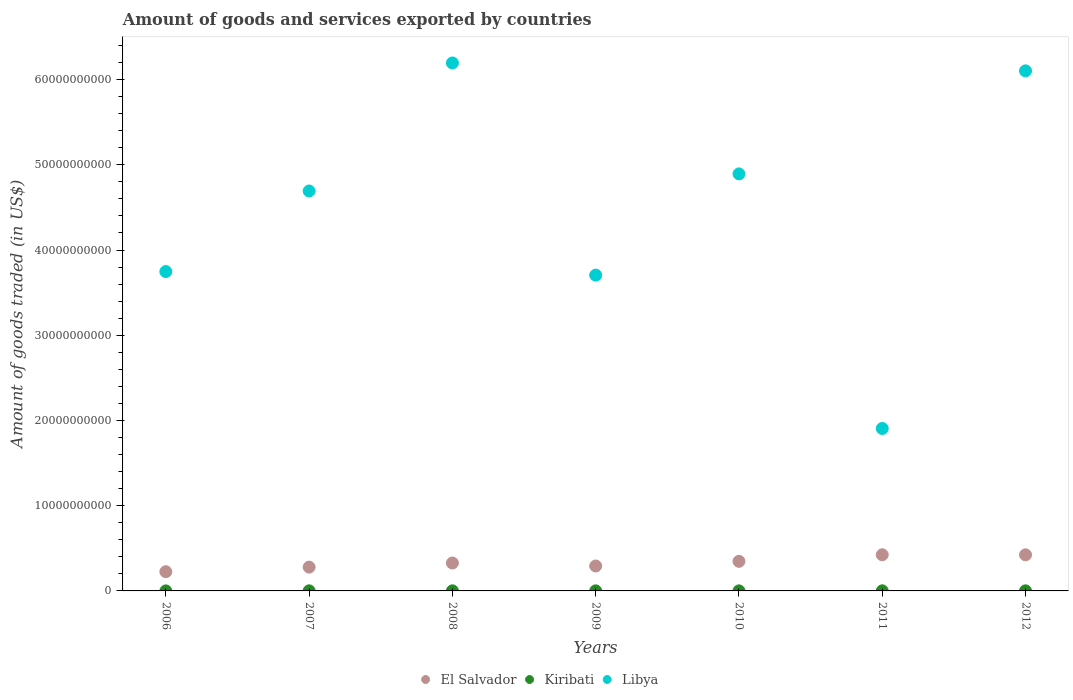How many different coloured dotlines are there?
Keep it short and to the point. 3. Is the number of dotlines equal to the number of legend labels?
Your response must be concise. Yes. What is the total amount of goods and services exported in Libya in 2007?
Offer a very short reply. 4.69e+1. Across all years, what is the maximum total amount of goods and services exported in Libya?
Offer a very short reply. 6.20e+1. Across all years, what is the minimum total amount of goods and services exported in El Salvador?
Provide a succinct answer. 2.25e+09. In which year was the total amount of goods and services exported in Libya maximum?
Your answer should be very brief. 2008. In which year was the total amount of goods and services exported in Libya minimum?
Make the answer very short. 2011. What is the total total amount of goods and services exported in Libya in the graph?
Give a very brief answer. 3.12e+11. What is the difference between the total amount of goods and services exported in Libya in 2009 and that in 2011?
Your response must be concise. 1.80e+1. What is the difference between the total amount of goods and services exported in El Salvador in 2006 and the total amount of goods and services exported in Kiribati in 2011?
Ensure brevity in your answer.  2.24e+09. What is the average total amount of goods and services exported in El Salvador per year?
Provide a succinct answer. 3.31e+09. In the year 2010, what is the difference between the total amount of goods and services exported in El Salvador and total amount of goods and services exported in Kiribati?
Offer a very short reply. 3.47e+09. What is the ratio of the total amount of goods and services exported in Kiribati in 2011 to that in 2012?
Provide a succinct answer. 1.13. Is the total amount of goods and services exported in Libya in 2006 less than that in 2009?
Your answer should be compact. No. What is the difference between the highest and the second highest total amount of goods and services exported in El Salvador?
Your answer should be very brief. 7.78e+06. What is the difference between the highest and the lowest total amount of goods and services exported in Kiribati?
Ensure brevity in your answer.  8.21e+06. In how many years, is the total amount of goods and services exported in Libya greater than the average total amount of goods and services exported in Libya taken over all years?
Offer a terse response. 4. Is it the case that in every year, the sum of the total amount of goods and services exported in Libya and total amount of goods and services exported in El Salvador  is greater than the total amount of goods and services exported in Kiribati?
Ensure brevity in your answer.  Yes. Does the total amount of goods and services exported in Kiribati monotonically increase over the years?
Provide a succinct answer. No. Is the total amount of goods and services exported in Libya strictly less than the total amount of goods and services exported in El Salvador over the years?
Offer a terse response. No. How many years are there in the graph?
Offer a very short reply. 7. What is the difference between two consecutive major ticks on the Y-axis?
Provide a succinct answer. 1.00e+1. Are the values on the major ticks of Y-axis written in scientific E-notation?
Provide a short and direct response. No. Where does the legend appear in the graph?
Ensure brevity in your answer.  Bottom center. How many legend labels are there?
Ensure brevity in your answer.  3. What is the title of the graph?
Give a very brief answer. Amount of goods and services exported by countries. Does "Northern Mariana Islands" appear as one of the legend labels in the graph?
Make the answer very short. No. What is the label or title of the Y-axis?
Offer a terse response. Amount of goods traded (in US$). What is the Amount of goods traded (in US$) of El Salvador in 2006?
Provide a short and direct response. 2.25e+09. What is the Amount of goods traded (in US$) of Kiribati in 2006?
Make the answer very short. 3.27e+06. What is the Amount of goods traded (in US$) in Libya in 2006?
Provide a short and direct response. 3.75e+1. What is the Amount of goods traded (in US$) of El Salvador in 2007?
Your answer should be very brief. 2.79e+09. What is the Amount of goods traded (in US$) in Kiribati in 2007?
Ensure brevity in your answer.  1.13e+07. What is the Amount of goods traded (in US$) in Libya in 2007?
Your answer should be compact. 4.69e+1. What is the Amount of goods traded (in US$) of El Salvador in 2008?
Give a very brief answer. 3.28e+09. What is the Amount of goods traded (in US$) in Kiribati in 2008?
Your response must be concise. 9.18e+06. What is the Amount of goods traded (in US$) of Libya in 2008?
Offer a terse response. 6.20e+1. What is the Amount of goods traded (in US$) of El Salvador in 2009?
Your answer should be compact. 2.92e+09. What is the Amount of goods traded (in US$) in Kiribati in 2009?
Keep it short and to the point. 7.42e+06. What is the Amount of goods traded (in US$) in Libya in 2009?
Give a very brief answer. 3.71e+1. What is the Amount of goods traded (in US$) in El Salvador in 2010?
Your answer should be very brief. 3.47e+09. What is the Amount of goods traded (in US$) in Kiribati in 2010?
Provide a short and direct response. 6.66e+06. What is the Amount of goods traded (in US$) of Libya in 2010?
Offer a very short reply. 4.89e+1. What is the Amount of goods traded (in US$) in El Salvador in 2011?
Offer a very short reply. 4.24e+09. What is the Amount of goods traded (in US$) in Kiribati in 2011?
Offer a very short reply. 1.15e+07. What is the Amount of goods traded (in US$) of Libya in 2011?
Your response must be concise. 1.91e+1. What is the Amount of goods traded (in US$) of El Salvador in 2012?
Offer a very short reply. 4.23e+09. What is the Amount of goods traded (in US$) in Kiribati in 2012?
Keep it short and to the point. 1.02e+07. What is the Amount of goods traded (in US$) of Libya in 2012?
Give a very brief answer. 6.10e+1. Across all years, what is the maximum Amount of goods traded (in US$) in El Salvador?
Provide a succinct answer. 4.24e+09. Across all years, what is the maximum Amount of goods traded (in US$) of Kiribati?
Give a very brief answer. 1.15e+07. Across all years, what is the maximum Amount of goods traded (in US$) of Libya?
Offer a very short reply. 6.20e+1. Across all years, what is the minimum Amount of goods traded (in US$) of El Salvador?
Provide a succinct answer. 2.25e+09. Across all years, what is the minimum Amount of goods traded (in US$) in Kiribati?
Give a very brief answer. 3.27e+06. Across all years, what is the minimum Amount of goods traded (in US$) in Libya?
Offer a very short reply. 1.91e+1. What is the total Amount of goods traded (in US$) in El Salvador in the graph?
Your response must be concise. 2.32e+1. What is the total Amount of goods traded (in US$) in Kiribati in the graph?
Keep it short and to the point. 5.95e+07. What is the total Amount of goods traded (in US$) in Libya in the graph?
Make the answer very short. 3.12e+11. What is the difference between the Amount of goods traded (in US$) of El Salvador in 2006 and that in 2007?
Your response must be concise. -5.39e+08. What is the difference between the Amount of goods traded (in US$) in Kiribati in 2006 and that in 2007?
Provide a succinct answer. -7.99e+06. What is the difference between the Amount of goods traded (in US$) of Libya in 2006 and that in 2007?
Keep it short and to the point. -9.46e+09. What is the difference between the Amount of goods traded (in US$) in El Salvador in 2006 and that in 2008?
Offer a very short reply. -1.02e+09. What is the difference between the Amount of goods traded (in US$) in Kiribati in 2006 and that in 2008?
Your answer should be compact. -5.91e+06. What is the difference between the Amount of goods traded (in US$) in Libya in 2006 and that in 2008?
Offer a very short reply. -2.45e+1. What is the difference between the Amount of goods traded (in US$) in El Salvador in 2006 and that in 2009?
Your answer should be very brief. -6.69e+08. What is the difference between the Amount of goods traded (in US$) of Kiribati in 2006 and that in 2009?
Ensure brevity in your answer.  -4.14e+06. What is the difference between the Amount of goods traded (in US$) in Libya in 2006 and that in 2009?
Offer a very short reply. 4.18e+08. What is the difference between the Amount of goods traded (in US$) in El Salvador in 2006 and that in 2010?
Your answer should be very brief. -1.22e+09. What is the difference between the Amount of goods traded (in US$) of Kiribati in 2006 and that in 2010?
Provide a succinct answer. -3.39e+06. What is the difference between the Amount of goods traded (in US$) of Libya in 2006 and that in 2010?
Your answer should be very brief. -1.15e+1. What is the difference between the Amount of goods traded (in US$) of El Salvador in 2006 and that in 2011?
Provide a short and direct response. -1.99e+09. What is the difference between the Amount of goods traded (in US$) in Kiribati in 2006 and that in 2011?
Your answer should be compact. -8.21e+06. What is the difference between the Amount of goods traded (in US$) in Libya in 2006 and that in 2011?
Offer a very short reply. 1.84e+1. What is the difference between the Amount of goods traded (in US$) of El Salvador in 2006 and that in 2012?
Ensure brevity in your answer.  -1.98e+09. What is the difference between the Amount of goods traded (in US$) of Kiribati in 2006 and that in 2012?
Make the answer very short. -6.92e+06. What is the difference between the Amount of goods traded (in US$) in Libya in 2006 and that in 2012?
Keep it short and to the point. -2.36e+1. What is the difference between the Amount of goods traded (in US$) in El Salvador in 2007 and that in 2008?
Your answer should be very brief. -4.82e+08. What is the difference between the Amount of goods traded (in US$) in Kiribati in 2007 and that in 2008?
Your response must be concise. 2.08e+06. What is the difference between the Amount of goods traded (in US$) in Libya in 2007 and that in 2008?
Your response must be concise. -1.50e+1. What is the difference between the Amount of goods traded (in US$) of El Salvador in 2007 and that in 2009?
Offer a very short reply. -1.30e+08. What is the difference between the Amount of goods traded (in US$) in Kiribati in 2007 and that in 2009?
Your response must be concise. 3.85e+06. What is the difference between the Amount of goods traded (in US$) in Libya in 2007 and that in 2009?
Make the answer very short. 9.87e+09. What is the difference between the Amount of goods traded (in US$) in El Salvador in 2007 and that in 2010?
Give a very brief answer. -6.79e+08. What is the difference between the Amount of goods traded (in US$) in Kiribati in 2007 and that in 2010?
Your response must be concise. 4.60e+06. What is the difference between the Amount of goods traded (in US$) in Libya in 2007 and that in 2010?
Make the answer very short. -2.01e+09. What is the difference between the Amount of goods traded (in US$) of El Salvador in 2007 and that in 2011?
Offer a very short reply. -1.45e+09. What is the difference between the Amount of goods traded (in US$) in Kiribati in 2007 and that in 2011?
Offer a very short reply. -2.15e+05. What is the difference between the Amount of goods traded (in US$) in Libya in 2007 and that in 2011?
Offer a very short reply. 2.79e+1. What is the difference between the Amount of goods traded (in US$) in El Salvador in 2007 and that in 2012?
Keep it short and to the point. -1.44e+09. What is the difference between the Amount of goods traded (in US$) of Kiribati in 2007 and that in 2012?
Your answer should be very brief. 1.07e+06. What is the difference between the Amount of goods traded (in US$) of Libya in 2007 and that in 2012?
Offer a terse response. -1.41e+1. What is the difference between the Amount of goods traded (in US$) of El Salvador in 2008 and that in 2009?
Keep it short and to the point. 3.52e+08. What is the difference between the Amount of goods traded (in US$) in Kiribati in 2008 and that in 2009?
Make the answer very short. 1.76e+06. What is the difference between the Amount of goods traded (in US$) in Libya in 2008 and that in 2009?
Ensure brevity in your answer.  2.49e+1. What is the difference between the Amount of goods traded (in US$) of El Salvador in 2008 and that in 2010?
Ensure brevity in your answer.  -1.98e+08. What is the difference between the Amount of goods traded (in US$) of Kiribati in 2008 and that in 2010?
Provide a succinct answer. 2.52e+06. What is the difference between the Amount of goods traded (in US$) of Libya in 2008 and that in 2010?
Make the answer very short. 1.30e+1. What is the difference between the Amount of goods traded (in US$) of El Salvador in 2008 and that in 2011?
Provide a short and direct response. -9.67e+08. What is the difference between the Amount of goods traded (in US$) in Kiribati in 2008 and that in 2011?
Your response must be concise. -2.30e+06. What is the difference between the Amount of goods traded (in US$) of Libya in 2008 and that in 2011?
Your response must be concise. 4.29e+1. What is the difference between the Amount of goods traded (in US$) of El Salvador in 2008 and that in 2012?
Keep it short and to the point. -9.59e+08. What is the difference between the Amount of goods traded (in US$) of Kiribati in 2008 and that in 2012?
Offer a terse response. -1.01e+06. What is the difference between the Amount of goods traded (in US$) of Libya in 2008 and that in 2012?
Your answer should be compact. 9.24e+08. What is the difference between the Amount of goods traded (in US$) of El Salvador in 2009 and that in 2010?
Ensure brevity in your answer.  -5.50e+08. What is the difference between the Amount of goods traded (in US$) in Kiribati in 2009 and that in 2010?
Provide a short and direct response. 7.58e+05. What is the difference between the Amount of goods traded (in US$) in Libya in 2009 and that in 2010?
Ensure brevity in your answer.  -1.19e+1. What is the difference between the Amount of goods traded (in US$) in El Salvador in 2009 and that in 2011?
Ensure brevity in your answer.  -1.32e+09. What is the difference between the Amount of goods traded (in US$) in Kiribati in 2009 and that in 2011?
Your response must be concise. -4.06e+06. What is the difference between the Amount of goods traded (in US$) of Libya in 2009 and that in 2011?
Offer a very short reply. 1.80e+1. What is the difference between the Amount of goods traded (in US$) in El Salvador in 2009 and that in 2012?
Give a very brief answer. -1.31e+09. What is the difference between the Amount of goods traded (in US$) of Kiribati in 2009 and that in 2012?
Give a very brief answer. -2.77e+06. What is the difference between the Amount of goods traded (in US$) of Libya in 2009 and that in 2012?
Provide a succinct answer. -2.40e+1. What is the difference between the Amount of goods traded (in US$) of El Salvador in 2010 and that in 2011?
Provide a short and direct response. -7.69e+08. What is the difference between the Amount of goods traded (in US$) of Kiribati in 2010 and that in 2011?
Keep it short and to the point. -4.82e+06. What is the difference between the Amount of goods traded (in US$) in Libya in 2010 and that in 2011?
Ensure brevity in your answer.  2.99e+1. What is the difference between the Amount of goods traded (in US$) in El Salvador in 2010 and that in 2012?
Keep it short and to the point. -7.62e+08. What is the difference between the Amount of goods traded (in US$) of Kiribati in 2010 and that in 2012?
Your answer should be very brief. -3.53e+06. What is the difference between the Amount of goods traded (in US$) in Libya in 2010 and that in 2012?
Ensure brevity in your answer.  -1.21e+1. What is the difference between the Amount of goods traded (in US$) in El Salvador in 2011 and that in 2012?
Provide a succinct answer. 7.78e+06. What is the difference between the Amount of goods traded (in US$) of Kiribati in 2011 and that in 2012?
Your answer should be compact. 1.29e+06. What is the difference between the Amount of goods traded (in US$) in Libya in 2011 and that in 2012?
Offer a very short reply. -4.20e+1. What is the difference between the Amount of goods traded (in US$) in El Salvador in 2006 and the Amount of goods traded (in US$) in Kiribati in 2007?
Keep it short and to the point. 2.24e+09. What is the difference between the Amount of goods traded (in US$) of El Salvador in 2006 and the Amount of goods traded (in US$) of Libya in 2007?
Give a very brief answer. -4.47e+1. What is the difference between the Amount of goods traded (in US$) in Kiribati in 2006 and the Amount of goods traded (in US$) in Libya in 2007?
Make the answer very short. -4.69e+1. What is the difference between the Amount of goods traded (in US$) of El Salvador in 2006 and the Amount of goods traded (in US$) of Kiribati in 2008?
Your answer should be very brief. 2.25e+09. What is the difference between the Amount of goods traded (in US$) of El Salvador in 2006 and the Amount of goods traded (in US$) of Libya in 2008?
Your answer should be compact. -5.97e+1. What is the difference between the Amount of goods traded (in US$) in Kiribati in 2006 and the Amount of goods traded (in US$) in Libya in 2008?
Give a very brief answer. -6.19e+1. What is the difference between the Amount of goods traded (in US$) in El Salvador in 2006 and the Amount of goods traded (in US$) in Kiribati in 2009?
Provide a short and direct response. 2.25e+09. What is the difference between the Amount of goods traded (in US$) in El Salvador in 2006 and the Amount of goods traded (in US$) in Libya in 2009?
Make the answer very short. -3.48e+1. What is the difference between the Amount of goods traded (in US$) in Kiribati in 2006 and the Amount of goods traded (in US$) in Libya in 2009?
Your answer should be very brief. -3.71e+1. What is the difference between the Amount of goods traded (in US$) in El Salvador in 2006 and the Amount of goods traded (in US$) in Kiribati in 2010?
Your answer should be compact. 2.25e+09. What is the difference between the Amount of goods traded (in US$) in El Salvador in 2006 and the Amount of goods traded (in US$) in Libya in 2010?
Keep it short and to the point. -4.67e+1. What is the difference between the Amount of goods traded (in US$) in Kiribati in 2006 and the Amount of goods traded (in US$) in Libya in 2010?
Provide a succinct answer. -4.89e+1. What is the difference between the Amount of goods traded (in US$) in El Salvador in 2006 and the Amount of goods traded (in US$) in Kiribati in 2011?
Your response must be concise. 2.24e+09. What is the difference between the Amount of goods traded (in US$) of El Salvador in 2006 and the Amount of goods traded (in US$) of Libya in 2011?
Your answer should be compact. -1.68e+1. What is the difference between the Amount of goods traded (in US$) in Kiribati in 2006 and the Amount of goods traded (in US$) in Libya in 2011?
Your answer should be compact. -1.91e+1. What is the difference between the Amount of goods traded (in US$) in El Salvador in 2006 and the Amount of goods traded (in US$) in Kiribati in 2012?
Keep it short and to the point. 2.24e+09. What is the difference between the Amount of goods traded (in US$) in El Salvador in 2006 and the Amount of goods traded (in US$) in Libya in 2012?
Keep it short and to the point. -5.88e+1. What is the difference between the Amount of goods traded (in US$) in Kiribati in 2006 and the Amount of goods traded (in US$) in Libya in 2012?
Provide a short and direct response. -6.10e+1. What is the difference between the Amount of goods traded (in US$) of El Salvador in 2007 and the Amount of goods traded (in US$) of Kiribati in 2008?
Offer a very short reply. 2.78e+09. What is the difference between the Amount of goods traded (in US$) of El Salvador in 2007 and the Amount of goods traded (in US$) of Libya in 2008?
Offer a terse response. -5.92e+1. What is the difference between the Amount of goods traded (in US$) in Kiribati in 2007 and the Amount of goods traded (in US$) in Libya in 2008?
Your answer should be very brief. -6.19e+1. What is the difference between the Amount of goods traded (in US$) of El Salvador in 2007 and the Amount of goods traded (in US$) of Kiribati in 2009?
Offer a terse response. 2.79e+09. What is the difference between the Amount of goods traded (in US$) of El Salvador in 2007 and the Amount of goods traded (in US$) of Libya in 2009?
Keep it short and to the point. -3.43e+1. What is the difference between the Amount of goods traded (in US$) in Kiribati in 2007 and the Amount of goods traded (in US$) in Libya in 2009?
Provide a short and direct response. -3.70e+1. What is the difference between the Amount of goods traded (in US$) of El Salvador in 2007 and the Amount of goods traded (in US$) of Kiribati in 2010?
Offer a very short reply. 2.79e+09. What is the difference between the Amount of goods traded (in US$) in El Salvador in 2007 and the Amount of goods traded (in US$) in Libya in 2010?
Offer a terse response. -4.61e+1. What is the difference between the Amount of goods traded (in US$) of Kiribati in 2007 and the Amount of goods traded (in US$) of Libya in 2010?
Provide a succinct answer. -4.89e+1. What is the difference between the Amount of goods traded (in US$) of El Salvador in 2007 and the Amount of goods traded (in US$) of Kiribati in 2011?
Your answer should be very brief. 2.78e+09. What is the difference between the Amount of goods traded (in US$) of El Salvador in 2007 and the Amount of goods traded (in US$) of Libya in 2011?
Make the answer very short. -1.63e+1. What is the difference between the Amount of goods traded (in US$) of Kiribati in 2007 and the Amount of goods traded (in US$) of Libya in 2011?
Give a very brief answer. -1.90e+1. What is the difference between the Amount of goods traded (in US$) of El Salvador in 2007 and the Amount of goods traded (in US$) of Kiribati in 2012?
Keep it short and to the point. 2.78e+09. What is the difference between the Amount of goods traded (in US$) of El Salvador in 2007 and the Amount of goods traded (in US$) of Libya in 2012?
Keep it short and to the point. -5.82e+1. What is the difference between the Amount of goods traded (in US$) of Kiribati in 2007 and the Amount of goods traded (in US$) of Libya in 2012?
Ensure brevity in your answer.  -6.10e+1. What is the difference between the Amount of goods traded (in US$) of El Salvador in 2008 and the Amount of goods traded (in US$) of Kiribati in 2009?
Your answer should be compact. 3.27e+09. What is the difference between the Amount of goods traded (in US$) in El Salvador in 2008 and the Amount of goods traded (in US$) in Libya in 2009?
Your response must be concise. -3.38e+1. What is the difference between the Amount of goods traded (in US$) in Kiribati in 2008 and the Amount of goods traded (in US$) in Libya in 2009?
Make the answer very short. -3.70e+1. What is the difference between the Amount of goods traded (in US$) in El Salvador in 2008 and the Amount of goods traded (in US$) in Kiribati in 2010?
Ensure brevity in your answer.  3.27e+09. What is the difference between the Amount of goods traded (in US$) of El Salvador in 2008 and the Amount of goods traded (in US$) of Libya in 2010?
Provide a succinct answer. -4.57e+1. What is the difference between the Amount of goods traded (in US$) in Kiribati in 2008 and the Amount of goods traded (in US$) in Libya in 2010?
Offer a very short reply. -4.89e+1. What is the difference between the Amount of goods traded (in US$) in El Salvador in 2008 and the Amount of goods traded (in US$) in Kiribati in 2011?
Keep it short and to the point. 3.26e+09. What is the difference between the Amount of goods traded (in US$) in El Salvador in 2008 and the Amount of goods traded (in US$) in Libya in 2011?
Make the answer very short. -1.58e+1. What is the difference between the Amount of goods traded (in US$) of Kiribati in 2008 and the Amount of goods traded (in US$) of Libya in 2011?
Make the answer very short. -1.91e+1. What is the difference between the Amount of goods traded (in US$) of El Salvador in 2008 and the Amount of goods traded (in US$) of Kiribati in 2012?
Your response must be concise. 3.27e+09. What is the difference between the Amount of goods traded (in US$) of El Salvador in 2008 and the Amount of goods traded (in US$) of Libya in 2012?
Your response must be concise. -5.78e+1. What is the difference between the Amount of goods traded (in US$) in Kiribati in 2008 and the Amount of goods traded (in US$) in Libya in 2012?
Your answer should be compact. -6.10e+1. What is the difference between the Amount of goods traded (in US$) of El Salvador in 2009 and the Amount of goods traded (in US$) of Kiribati in 2010?
Ensure brevity in your answer.  2.92e+09. What is the difference between the Amount of goods traded (in US$) of El Salvador in 2009 and the Amount of goods traded (in US$) of Libya in 2010?
Ensure brevity in your answer.  -4.60e+1. What is the difference between the Amount of goods traded (in US$) in Kiribati in 2009 and the Amount of goods traded (in US$) in Libya in 2010?
Offer a very short reply. -4.89e+1. What is the difference between the Amount of goods traded (in US$) in El Salvador in 2009 and the Amount of goods traded (in US$) in Kiribati in 2011?
Make the answer very short. 2.91e+09. What is the difference between the Amount of goods traded (in US$) in El Salvador in 2009 and the Amount of goods traded (in US$) in Libya in 2011?
Make the answer very short. -1.61e+1. What is the difference between the Amount of goods traded (in US$) of Kiribati in 2009 and the Amount of goods traded (in US$) of Libya in 2011?
Provide a succinct answer. -1.91e+1. What is the difference between the Amount of goods traded (in US$) in El Salvador in 2009 and the Amount of goods traded (in US$) in Kiribati in 2012?
Make the answer very short. 2.91e+09. What is the difference between the Amount of goods traded (in US$) of El Salvador in 2009 and the Amount of goods traded (in US$) of Libya in 2012?
Your response must be concise. -5.81e+1. What is the difference between the Amount of goods traded (in US$) in Kiribati in 2009 and the Amount of goods traded (in US$) in Libya in 2012?
Provide a succinct answer. -6.10e+1. What is the difference between the Amount of goods traded (in US$) in El Salvador in 2010 and the Amount of goods traded (in US$) in Kiribati in 2011?
Offer a terse response. 3.46e+09. What is the difference between the Amount of goods traded (in US$) of El Salvador in 2010 and the Amount of goods traded (in US$) of Libya in 2011?
Offer a terse response. -1.56e+1. What is the difference between the Amount of goods traded (in US$) of Kiribati in 2010 and the Amount of goods traded (in US$) of Libya in 2011?
Offer a terse response. -1.91e+1. What is the difference between the Amount of goods traded (in US$) in El Salvador in 2010 and the Amount of goods traded (in US$) in Kiribati in 2012?
Offer a very short reply. 3.46e+09. What is the difference between the Amount of goods traded (in US$) in El Salvador in 2010 and the Amount of goods traded (in US$) in Libya in 2012?
Your answer should be compact. -5.76e+1. What is the difference between the Amount of goods traded (in US$) of Kiribati in 2010 and the Amount of goods traded (in US$) of Libya in 2012?
Your response must be concise. -6.10e+1. What is the difference between the Amount of goods traded (in US$) of El Salvador in 2011 and the Amount of goods traded (in US$) of Kiribati in 2012?
Provide a short and direct response. 4.23e+09. What is the difference between the Amount of goods traded (in US$) in El Salvador in 2011 and the Amount of goods traded (in US$) in Libya in 2012?
Keep it short and to the point. -5.68e+1. What is the difference between the Amount of goods traded (in US$) in Kiribati in 2011 and the Amount of goods traded (in US$) in Libya in 2012?
Keep it short and to the point. -6.10e+1. What is the average Amount of goods traded (in US$) of El Salvador per year?
Your response must be concise. 3.31e+09. What is the average Amount of goods traded (in US$) in Kiribati per year?
Your answer should be compact. 8.49e+06. What is the average Amount of goods traded (in US$) in Libya per year?
Keep it short and to the point. 4.46e+1. In the year 2006, what is the difference between the Amount of goods traded (in US$) of El Salvador and Amount of goods traded (in US$) of Kiribati?
Ensure brevity in your answer.  2.25e+09. In the year 2006, what is the difference between the Amount of goods traded (in US$) of El Salvador and Amount of goods traded (in US$) of Libya?
Make the answer very short. -3.52e+1. In the year 2006, what is the difference between the Amount of goods traded (in US$) in Kiribati and Amount of goods traded (in US$) in Libya?
Ensure brevity in your answer.  -3.75e+1. In the year 2007, what is the difference between the Amount of goods traded (in US$) of El Salvador and Amount of goods traded (in US$) of Kiribati?
Your response must be concise. 2.78e+09. In the year 2007, what is the difference between the Amount of goods traded (in US$) in El Salvador and Amount of goods traded (in US$) in Libya?
Provide a short and direct response. -4.41e+1. In the year 2007, what is the difference between the Amount of goods traded (in US$) of Kiribati and Amount of goods traded (in US$) of Libya?
Offer a very short reply. -4.69e+1. In the year 2008, what is the difference between the Amount of goods traded (in US$) of El Salvador and Amount of goods traded (in US$) of Kiribati?
Your answer should be compact. 3.27e+09. In the year 2008, what is the difference between the Amount of goods traded (in US$) in El Salvador and Amount of goods traded (in US$) in Libya?
Your answer should be compact. -5.87e+1. In the year 2008, what is the difference between the Amount of goods traded (in US$) in Kiribati and Amount of goods traded (in US$) in Libya?
Your answer should be compact. -6.19e+1. In the year 2009, what is the difference between the Amount of goods traded (in US$) of El Salvador and Amount of goods traded (in US$) of Kiribati?
Make the answer very short. 2.92e+09. In the year 2009, what is the difference between the Amount of goods traded (in US$) of El Salvador and Amount of goods traded (in US$) of Libya?
Provide a succinct answer. -3.41e+1. In the year 2009, what is the difference between the Amount of goods traded (in US$) of Kiribati and Amount of goods traded (in US$) of Libya?
Your answer should be very brief. -3.70e+1. In the year 2010, what is the difference between the Amount of goods traded (in US$) of El Salvador and Amount of goods traded (in US$) of Kiribati?
Make the answer very short. 3.47e+09. In the year 2010, what is the difference between the Amount of goods traded (in US$) in El Salvador and Amount of goods traded (in US$) in Libya?
Your answer should be compact. -4.55e+1. In the year 2010, what is the difference between the Amount of goods traded (in US$) in Kiribati and Amount of goods traded (in US$) in Libya?
Keep it short and to the point. -4.89e+1. In the year 2011, what is the difference between the Amount of goods traded (in US$) of El Salvador and Amount of goods traded (in US$) of Kiribati?
Offer a very short reply. 4.23e+09. In the year 2011, what is the difference between the Amount of goods traded (in US$) in El Salvador and Amount of goods traded (in US$) in Libya?
Offer a terse response. -1.48e+1. In the year 2011, what is the difference between the Amount of goods traded (in US$) of Kiribati and Amount of goods traded (in US$) of Libya?
Your answer should be very brief. -1.90e+1. In the year 2012, what is the difference between the Amount of goods traded (in US$) in El Salvador and Amount of goods traded (in US$) in Kiribati?
Give a very brief answer. 4.22e+09. In the year 2012, what is the difference between the Amount of goods traded (in US$) of El Salvador and Amount of goods traded (in US$) of Libya?
Offer a terse response. -5.68e+1. In the year 2012, what is the difference between the Amount of goods traded (in US$) of Kiribati and Amount of goods traded (in US$) of Libya?
Offer a very short reply. -6.10e+1. What is the ratio of the Amount of goods traded (in US$) of El Salvador in 2006 to that in 2007?
Your response must be concise. 0.81. What is the ratio of the Amount of goods traded (in US$) of Kiribati in 2006 to that in 2007?
Give a very brief answer. 0.29. What is the ratio of the Amount of goods traded (in US$) of Libya in 2006 to that in 2007?
Ensure brevity in your answer.  0.8. What is the ratio of the Amount of goods traded (in US$) in El Salvador in 2006 to that in 2008?
Make the answer very short. 0.69. What is the ratio of the Amount of goods traded (in US$) in Kiribati in 2006 to that in 2008?
Provide a short and direct response. 0.36. What is the ratio of the Amount of goods traded (in US$) in Libya in 2006 to that in 2008?
Ensure brevity in your answer.  0.6. What is the ratio of the Amount of goods traded (in US$) of El Salvador in 2006 to that in 2009?
Make the answer very short. 0.77. What is the ratio of the Amount of goods traded (in US$) of Kiribati in 2006 to that in 2009?
Give a very brief answer. 0.44. What is the ratio of the Amount of goods traded (in US$) of Libya in 2006 to that in 2009?
Your response must be concise. 1.01. What is the ratio of the Amount of goods traded (in US$) of El Salvador in 2006 to that in 2010?
Keep it short and to the point. 0.65. What is the ratio of the Amount of goods traded (in US$) in Kiribati in 2006 to that in 2010?
Provide a short and direct response. 0.49. What is the ratio of the Amount of goods traded (in US$) of Libya in 2006 to that in 2010?
Keep it short and to the point. 0.77. What is the ratio of the Amount of goods traded (in US$) in El Salvador in 2006 to that in 2011?
Provide a succinct answer. 0.53. What is the ratio of the Amount of goods traded (in US$) in Kiribati in 2006 to that in 2011?
Make the answer very short. 0.29. What is the ratio of the Amount of goods traded (in US$) of Libya in 2006 to that in 2011?
Keep it short and to the point. 1.97. What is the ratio of the Amount of goods traded (in US$) in El Salvador in 2006 to that in 2012?
Offer a very short reply. 0.53. What is the ratio of the Amount of goods traded (in US$) in Kiribati in 2006 to that in 2012?
Offer a terse response. 0.32. What is the ratio of the Amount of goods traded (in US$) of Libya in 2006 to that in 2012?
Keep it short and to the point. 0.61. What is the ratio of the Amount of goods traded (in US$) in El Salvador in 2007 to that in 2008?
Offer a terse response. 0.85. What is the ratio of the Amount of goods traded (in US$) of Kiribati in 2007 to that in 2008?
Your answer should be very brief. 1.23. What is the ratio of the Amount of goods traded (in US$) in Libya in 2007 to that in 2008?
Keep it short and to the point. 0.76. What is the ratio of the Amount of goods traded (in US$) of El Salvador in 2007 to that in 2009?
Your response must be concise. 0.96. What is the ratio of the Amount of goods traded (in US$) of Kiribati in 2007 to that in 2009?
Your answer should be very brief. 1.52. What is the ratio of the Amount of goods traded (in US$) in Libya in 2007 to that in 2009?
Offer a very short reply. 1.27. What is the ratio of the Amount of goods traded (in US$) in El Salvador in 2007 to that in 2010?
Offer a very short reply. 0.8. What is the ratio of the Amount of goods traded (in US$) of Kiribati in 2007 to that in 2010?
Keep it short and to the point. 1.69. What is the ratio of the Amount of goods traded (in US$) of Libya in 2007 to that in 2010?
Make the answer very short. 0.96. What is the ratio of the Amount of goods traded (in US$) of El Salvador in 2007 to that in 2011?
Give a very brief answer. 0.66. What is the ratio of the Amount of goods traded (in US$) in Kiribati in 2007 to that in 2011?
Your answer should be compact. 0.98. What is the ratio of the Amount of goods traded (in US$) in Libya in 2007 to that in 2011?
Offer a terse response. 2.46. What is the ratio of the Amount of goods traded (in US$) in El Salvador in 2007 to that in 2012?
Offer a terse response. 0.66. What is the ratio of the Amount of goods traded (in US$) in Kiribati in 2007 to that in 2012?
Give a very brief answer. 1.11. What is the ratio of the Amount of goods traded (in US$) in Libya in 2007 to that in 2012?
Your answer should be very brief. 0.77. What is the ratio of the Amount of goods traded (in US$) in El Salvador in 2008 to that in 2009?
Keep it short and to the point. 1.12. What is the ratio of the Amount of goods traded (in US$) in Kiribati in 2008 to that in 2009?
Your answer should be compact. 1.24. What is the ratio of the Amount of goods traded (in US$) of Libya in 2008 to that in 2009?
Give a very brief answer. 1.67. What is the ratio of the Amount of goods traded (in US$) of El Salvador in 2008 to that in 2010?
Offer a terse response. 0.94. What is the ratio of the Amount of goods traded (in US$) in Kiribati in 2008 to that in 2010?
Make the answer very short. 1.38. What is the ratio of the Amount of goods traded (in US$) of Libya in 2008 to that in 2010?
Make the answer very short. 1.27. What is the ratio of the Amount of goods traded (in US$) of El Salvador in 2008 to that in 2011?
Your answer should be compact. 0.77. What is the ratio of the Amount of goods traded (in US$) in Kiribati in 2008 to that in 2011?
Make the answer very short. 0.8. What is the ratio of the Amount of goods traded (in US$) of Libya in 2008 to that in 2011?
Offer a very short reply. 3.25. What is the ratio of the Amount of goods traded (in US$) in El Salvador in 2008 to that in 2012?
Provide a succinct answer. 0.77. What is the ratio of the Amount of goods traded (in US$) of Kiribati in 2008 to that in 2012?
Offer a very short reply. 0.9. What is the ratio of the Amount of goods traded (in US$) in Libya in 2008 to that in 2012?
Make the answer very short. 1.02. What is the ratio of the Amount of goods traded (in US$) in El Salvador in 2009 to that in 2010?
Provide a short and direct response. 0.84. What is the ratio of the Amount of goods traded (in US$) in Kiribati in 2009 to that in 2010?
Make the answer very short. 1.11. What is the ratio of the Amount of goods traded (in US$) in Libya in 2009 to that in 2010?
Your response must be concise. 0.76. What is the ratio of the Amount of goods traded (in US$) in El Salvador in 2009 to that in 2011?
Offer a very short reply. 0.69. What is the ratio of the Amount of goods traded (in US$) in Kiribati in 2009 to that in 2011?
Your answer should be compact. 0.65. What is the ratio of the Amount of goods traded (in US$) in Libya in 2009 to that in 2011?
Provide a succinct answer. 1.94. What is the ratio of the Amount of goods traded (in US$) of El Salvador in 2009 to that in 2012?
Your answer should be compact. 0.69. What is the ratio of the Amount of goods traded (in US$) in Kiribati in 2009 to that in 2012?
Make the answer very short. 0.73. What is the ratio of the Amount of goods traded (in US$) in Libya in 2009 to that in 2012?
Provide a succinct answer. 0.61. What is the ratio of the Amount of goods traded (in US$) of El Salvador in 2010 to that in 2011?
Provide a short and direct response. 0.82. What is the ratio of the Amount of goods traded (in US$) in Kiribati in 2010 to that in 2011?
Your response must be concise. 0.58. What is the ratio of the Amount of goods traded (in US$) of Libya in 2010 to that in 2011?
Give a very brief answer. 2.57. What is the ratio of the Amount of goods traded (in US$) in El Salvador in 2010 to that in 2012?
Your answer should be very brief. 0.82. What is the ratio of the Amount of goods traded (in US$) of Kiribati in 2010 to that in 2012?
Your response must be concise. 0.65. What is the ratio of the Amount of goods traded (in US$) in Libya in 2010 to that in 2012?
Make the answer very short. 0.8. What is the ratio of the Amount of goods traded (in US$) in Kiribati in 2011 to that in 2012?
Your answer should be compact. 1.13. What is the ratio of the Amount of goods traded (in US$) of Libya in 2011 to that in 2012?
Ensure brevity in your answer.  0.31. What is the difference between the highest and the second highest Amount of goods traded (in US$) in El Salvador?
Offer a terse response. 7.78e+06. What is the difference between the highest and the second highest Amount of goods traded (in US$) in Kiribati?
Make the answer very short. 2.15e+05. What is the difference between the highest and the second highest Amount of goods traded (in US$) in Libya?
Your answer should be compact. 9.24e+08. What is the difference between the highest and the lowest Amount of goods traded (in US$) in El Salvador?
Provide a succinct answer. 1.99e+09. What is the difference between the highest and the lowest Amount of goods traded (in US$) in Kiribati?
Provide a succinct answer. 8.21e+06. What is the difference between the highest and the lowest Amount of goods traded (in US$) in Libya?
Offer a very short reply. 4.29e+1. 